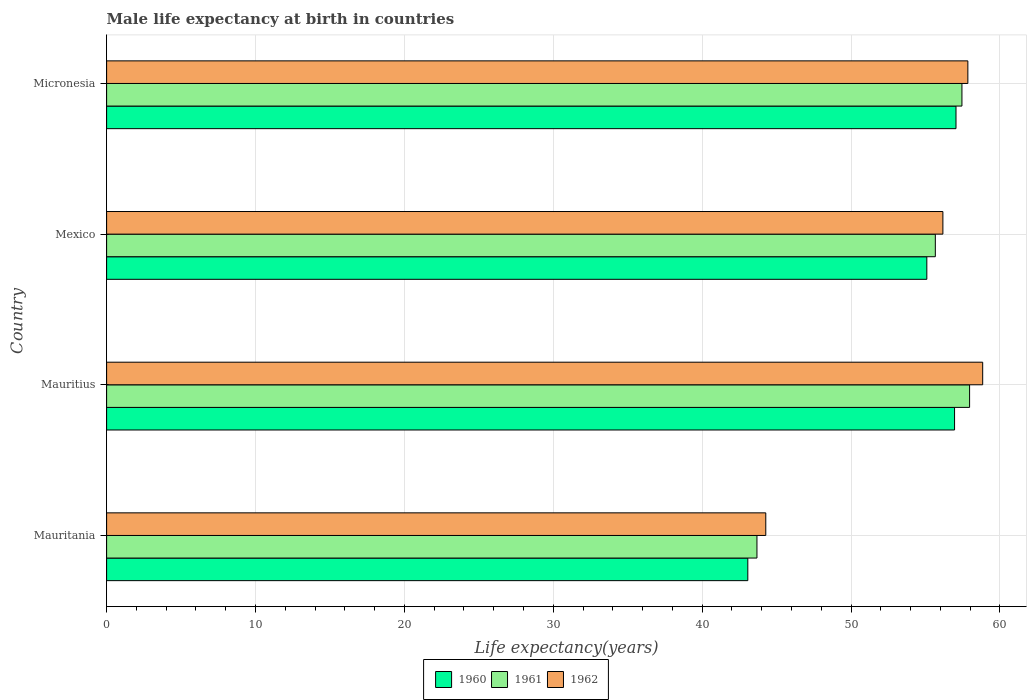Are the number of bars on each tick of the Y-axis equal?
Provide a succinct answer. Yes. How many bars are there on the 1st tick from the top?
Provide a short and direct response. 3. What is the label of the 4th group of bars from the top?
Keep it short and to the point. Mauritania. In how many cases, is the number of bars for a given country not equal to the number of legend labels?
Give a very brief answer. 0. What is the male life expectancy at birth in 1960 in Mauritania?
Keep it short and to the point. 43.07. Across all countries, what is the maximum male life expectancy at birth in 1962?
Ensure brevity in your answer.  58.84. Across all countries, what is the minimum male life expectancy at birth in 1960?
Your answer should be very brief. 43.07. In which country was the male life expectancy at birth in 1960 maximum?
Keep it short and to the point. Micronesia. In which country was the male life expectancy at birth in 1962 minimum?
Your answer should be compact. Mauritania. What is the total male life expectancy at birth in 1960 in the graph?
Offer a very short reply. 212.16. What is the difference between the male life expectancy at birth in 1962 in Mexico and that in Micronesia?
Your answer should be compact. -1.68. What is the difference between the male life expectancy at birth in 1960 in Mauritius and the male life expectancy at birth in 1961 in Mauritania?
Provide a short and direct response. 13.27. What is the average male life expectancy at birth in 1962 per country?
Make the answer very short. 54.28. What is the difference between the male life expectancy at birth in 1962 and male life expectancy at birth in 1961 in Micronesia?
Provide a succinct answer. 0.4. In how many countries, is the male life expectancy at birth in 1962 greater than 20 years?
Your answer should be very brief. 4. What is the ratio of the male life expectancy at birth in 1961 in Mexico to that in Micronesia?
Provide a short and direct response. 0.97. Is the male life expectancy at birth in 1962 in Mauritius less than that in Micronesia?
Your answer should be very brief. No. Is the difference between the male life expectancy at birth in 1962 in Mauritania and Mauritius greater than the difference between the male life expectancy at birth in 1961 in Mauritania and Mauritius?
Provide a short and direct response. No. What is the difference between the highest and the second highest male life expectancy at birth in 1961?
Provide a succinct answer. 0.51. What is the difference between the highest and the lowest male life expectancy at birth in 1960?
Your answer should be very brief. 13.98. What does the 2nd bar from the bottom in Micronesia represents?
Ensure brevity in your answer.  1961. Is it the case that in every country, the sum of the male life expectancy at birth in 1961 and male life expectancy at birth in 1960 is greater than the male life expectancy at birth in 1962?
Keep it short and to the point. Yes. How many bars are there?
Ensure brevity in your answer.  12. How many countries are there in the graph?
Your answer should be very brief. 4. What is the difference between two consecutive major ticks on the X-axis?
Provide a short and direct response. 10. Are the values on the major ticks of X-axis written in scientific E-notation?
Ensure brevity in your answer.  No. Does the graph contain any zero values?
Your answer should be very brief. No. Does the graph contain grids?
Provide a succinct answer. Yes. Where does the legend appear in the graph?
Make the answer very short. Bottom center. What is the title of the graph?
Your response must be concise. Male life expectancy at birth in countries. What is the label or title of the X-axis?
Make the answer very short. Life expectancy(years). What is the Life expectancy(years) of 1960 in Mauritania?
Give a very brief answer. 43.07. What is the Life expectancy(years) of 1961 in Mauritania?
Provide a short and direct response. 43.68. What is the Life expectancy(years) in 1962 in Mauritania?
Provide a succinct answer. 44.27. What is the Life expectancy(years) of 1960 in Mauritius?
Offer a very short reply. 56.95. What is the Life expectancy(years) of 1961 in Mauritius?
Provide a short and direct response. 57.96. What is the Life expectancy(years) in 1962 in Mauritius?
Ensure brevity in your answer.  58.84. What is the Life expectancy(years) in 1960 in Mexico?
Offer a very short reply. 55.09. What is the Life expectancy(years) in 1961 in Mexico?
Your answer should be compact. 55.66. What is the Life expectancy(years) of 1962 in Mexico?
Offer a terse response. 56.17. What is the Life expectancy(years) of 1960 in Micronesia?
Ensure brevity in your answer.  57.05. What is the Life expectancy(years) of 1961 in Micronesia?
Your response must be concise. 57.45. What is the Life expectancy(years) of 1962 in Micronesia?
Your answer should be compact. 57.85. Across all countries, what is the maximum Life expectancy(years) in 1960?
Ensure brevity in your answer.  57.05. Across all countries, what is the maximum Life expectancy(years) in 1961?
Your response must be concise. 57.96. Across all countries, what is the maximum Life expectancy(years) in 1962?
Provide a short and direct response. 58.84. Across all countries, what is the minimum Life expectancy(years) of 1960?
Give a very brief answer. 43.07. Across all countries, what is the minimum Life expectancy(years) of 1961?
Keep it short and to the point. 43.68. Across all countries, what is the minimum Life expectancy(years) in 1962?
Provide a succinct answer. 44.27. What is the total Life expectancy(years) in 1960 in the graph?
Provide a succinct answer. 212.16. What is the total Life expectancy(years) of 1961 in the graph?
Provide a succinct answer. 214.75. What is the total Life expectancy(years) of 1962 in the graph?
Make the answer very short. 217.13. What is the difference between the Life expectancy(years) in 1960 in Mauritania and that in Mauritius?
Your answer should be compact. -13.89. What is the difference between the Life expectancy(years) of 1961 in Mauritania and that in Mauritius?
Your response must be concise. -14.28. What is the difference between the Life expectancy(years) in 1962 in Mauritania and that in Mauritius?
Your response must be concise. -14.57. What is the difference between the Life expectancy(years) in 1960 in Mauritania and that in Mexico?
Provide a short and direct response. -12.02. What is the difference between the Life expectancy(years) of 1961 in Mauritania and that in Mexico?
Keep it short and to the point. -11.98. What is the difference between the Life expectancy(years) of 1962 in Mauritania and that in Mexico?
Your answer should be very brief. -11.9. What is the difference between the Life expectancy(years) in 1960 in Mauritania and that in Micronesia?
Offer a terse response. -13.98. What is the difference between the Life expectancy(years) of 1961 in Mauritania and that in Micronesia?
Keep it short and to the point. -13.77. What is the difference between the Life expectancy(years) in 1962 in Mauritania and that in Micronesia?
Offer a terse response. -13.57. What is the difference between the Life expectancy(years) of 1960 in Mauritius and that in Mexico?
Make the answer very short. 1.86. What is the difference between the Life expectancy(years) in 1961 in Mauritius and that in Mexico?
Provide a short and direct response. 2.3. What is the difference between the Life expectancy(years) of 1962 in Mauritius and that in Mexico?
Provide a succinct answer. 2.67. What is the difference between the Life expectancy(years) of 1960 in Mauritius and that in Micronesia?
Provide a succinct answer. -0.1. What is the difference between the Life expectancy(years) in 1961 in Mauritius and that in Micronesia?
Make the answer very short. 0.51. What is the difference between the Life expectancy(years) in 1960 in Mexico and that in Micronesia?
Ensure brevity in your answer.  -1.96. What is the difference between the Life expectancy(years) of 1961 in Mexico and that in Micronesia?
Your answer should be very brief. -1.79. What is the difference between the Life expectancy(years) of 1962 in Mexico and that in Micronesia?
Give a very brief answer. -1.68. What is the difference between the Life expectancy(years) in 1960 in Mauritania and the Life expectancy(years) in 1961 in Mauritius?
Your answer should be very brief. -14.9. What is the difference between the Life expectancy(years) in 1960 in Mauritania and the Life expectancy(years) in 1962 in Mauritius?
Your response must be concise. -15.78. What is the difference between the Life expectancy(years) in 1961 in Mauritania and the Life expectancy(years) in 1962 in Mauritius?
Make the answer very short. -15.16. What is the difference between the Life expectancy(years) in 1960 in Mauritania and the Life expectancy(years) in 1961 in Mexico?
Provide a short and direct response. -12.6. What is the difference between the Life expectancy(years) of 1960 in Mauritania and the Life expectancy(years) of 1962 in Mexico?
Offer a very short reply. -13.1. What is the difference between the Life expectancy(years) in 1961 in Mauritania and the Life expectancy(years) in 1962 in Mexico?
Provide a short and direct response. -12.49. What is the difference between the Life expectancy(years) of 1960 in Mauritania and the Life expectancy(years) of 1961 in Micronesia?
Provide a short and direct response. -14.38. What is the difference between the Life expectancy(years) of 1960 in Mauritania and the Life expectancy(years) of 1962 in Micronesia?
Your answer should be very brief. -14.78. What is the difference between the Life expectancy(years) of 1961 in Mauritania and the Life expectancy(years) of 1962 in Micronesia?
Your answer should be compact. -14.17. What is the difference between the Life expectancy(years) of 1960 in Mauritius and the Life expectancy(years) of 1961 in Mexico?
Offer a very short reply. 1.29. What is the difference between the Life expectancy(years) in 1960 in Mauritius and the Life expectancy(years) in 1962 in Mexico?
Ensure brevity in your answer.  0.78. What is the difference between the Life expectancy(years) of 1961 in Mauritius and the Life expectancy(years) of 1962 in Mexico?
Provide a short and direct response. 1.79. What is the difference between the Life expectancy(years) in 1960 in Mauritius and the Life expectancy(years) in 1961 in Micronesia?
Keep it short and to the point. -0.49. What is the difference between the Life expectancy(years) of 1960 in Mauritius and the Life expectancy(years) of 1962 in Micronesia?
Give a very brief answer. -0.89. What is the difference between the Life expectancy(years) in 1961 in Mauritius and the Life expectancy(years) in 1962 in Micronesia?
Provide a short and direct response. 0.12. What is the difference between the Life expectancy(years) of 1960 in Mexico and the Life expectancy(years) of 1961 in Micronesia?
Provide a succinct answer. -2.36. What is the difference between the Life expectancy(years) of 1960 in Mexico and the Life expectancy(years) of 1962 in Micronesia?
Offer a very short reply. -2.76. What is the difference between the Life expectancy(years) in 1961 in Mexico and the Life expectancy(years) in 1962 in Micronesia?
Make the answer very short. -2.19. What is the average Life expectancy(years) in 1960 per country?
Your response must be concise. 53.04. What is the average Life expectancy(years) in 1961 per country?
Offer a terse response. 53.69. What is the average Life expectancy(years) in 1962 per country?
Offer a terse response. 54.28. What is the difference between the Life expectancy(years) in 1960 and Life expectancy(years) in 1961 in Mauritania?
Give a very brief answer. -0.61. What is the difference between the Life expectancy(years) of 1960 and Life expectancy(years) of 1962 in Mauritania?
Keep it short and to the point. -1.21. What is the difference between the Life expectancy(years) in 1961 and Life expectancy(years) in 1962 in Mauritania?
Keep it short and to the point. -0.59. What is the difference between the Life expectancy(years) of 1960 and Life expectancy(years) of 1961 in Mauritius?
Keep it short and to the point. -1.01. What is the difference between the Life expectancy(years) of 1960 and Life expectancy(years) of 1962 in Mauritius?
Your answer should be compact. -1.89. What is the difference between the Life expectancy(years) of 1961 and Life expectancy(years) of 1962 in Mauritius?
Your response must be concise. -0.88. What is the difference between the Life expectancy(years) of 1960 and Life expectancy(years) of 1961 in Mexico?
Your response must be concise. -0.57. What is the difference between the Life expectancy(years) in 1960 and Life expectancy(years) in 1962 in Mexico?
Your response must be concise. -1.08. What is the difference between the Life expectancy(years) of 1961 and Life expectancy(years) of 1962 in Mexico?
Offer a terse response. -0.51. What is the difference between the Life expectancy(years) in 1960 and Life expectancy(years) in 1961 in Micronesia?
Your answer should be very brief. -0.4. What is the difference between the Life expectancy(years) in 1960 and Life expectancy(years) in 1962 in Micronesia?
Your answer should be very brief. -0.8. What is the difference between the Life expectancy(years) of 1961 and Life expectancy(years) of 1962 in Micronesia?
Keep it short and to the point. -0.4. What is the ratio of the Life expectancy(years) in 1960 in Mauritania to that in Mauritius?
Provide a succinct answer. 0.76. What is the ratio of the Life expectancy(years) in 1961 in Mauritania to that in Mauritius?
Your answer should be compact. 0.75. What is the ratio of the Life expectancy(years) in 1962 in Mauritania to that in Mauritius?
Provide a short and direct response. 0.75. What is the ratio of the Life expectancy(years) in 1960 in Mauritania to that in Mexico?
Make the answer very short. 0.78. What is the ratio of the Life expectancy(years) in 1961 in Mauritania to that in Mexico?
Your answer should be very brief. 0.78. What is the ratio of the Life expectancy(years) in 1962 in Mauritania to that in Mexico?
Offer a terse response. 0.79. What is the ratio of the Life expectancy(years) of 1960 in Mauritania to that in Micronesia?
Ensure brevity in your answer.  0.75. What is the ratio of the Life expectancy(years) in 1961 in Mauritania to that in Micronesia?
Offer a very short reply. 0.76. What is the ratio of the Life expectancy(years) of 1962 in Mauritania to that in Micronesia?
Offer a very short reply. 0.77. What is the ratio of the Life expectancy(years) of 1960 in Mauritius to that in Mexico?
Provide a short and direct response. 1.03. What is the ratio of the Life expectancy(years) of 1961 in Mauritius to that in Mexico?
Provide a short and direct response. 1.04. What is the ratio of the Life expectancy(years) in 1962 in Mauritius to that in Mexico?
Your answer should be compact. 1.05. What is the ratio of the Life expectancy(years) of 1961 in Mauritius to that in Micronesia?
Make the answer very short. 1.01. What is the ratio of the Life expectancy(years) of 1962 in Mauritius to that in Micronesia?
Offer a terse response. 1.02. What is the ratio of the Life expectancy(years) of 1960 in Mexico to that in Micronesia?
Offer a terse response. 0.97. What is the ratio of the Life expectancy(years) of 1961 in Mexico to that in Micronesia?
Your answer should be very brief. 0.97. What is the difference between the highest and the second highest Life expectancy(years) in 1960?
Offer a very short reply. 0.1. What is the difference between the highest and the second highest Life expectancy(years) in 1961?
Give a very brief answer. 0.51. What is the difference between the highest and the lowest Life expectancy(years) of 1960?
Your answer should be very brief. 13.98. What is the difference between the highest and the lowest Life expectancy(years) in 1961?
Your answer should be very brief. 14.28. What is the difference between the highest and the lowest Life expectancy(years) in 1962?
Your answer should be very brief. 14.57. 